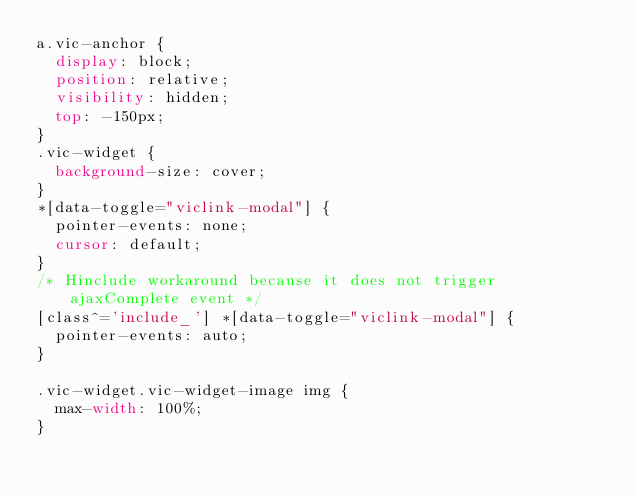Convert code to text. <code><loc_0><loc_0><loc_500><loc_500><_CSS_>a.vic-anchor {
  display: block;
  position: relative;
  visibility: hidden;
  top: -150px;
}
.vic-widget {
  background-size: cover;
}
*[data-toggle="viclink-modal"] {
  pointer-events: none;
  cursor: default;
}
/* Hinclude workaround because it does not trigger ajaxComplete event */
[class^='include_'] *[data-toggle="viclink-modal"] {
  pointer-events: auto;
}

.vic-widget.vic-widget-image img {
  max-width: 100%;
}
</code> 